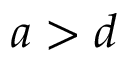Convert formula to latex. <formula><loc_0><loc_0><loc_500><loc_500>a > d</formula> 